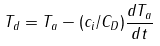Convert formula to latex. <formula><loc_0><loc_0><loc_500><loc_500>T _ { d } = T _ { a } - ( c _ { i } / C _ { D } ) \frac { d T _ { a } } { d t }</formula> 